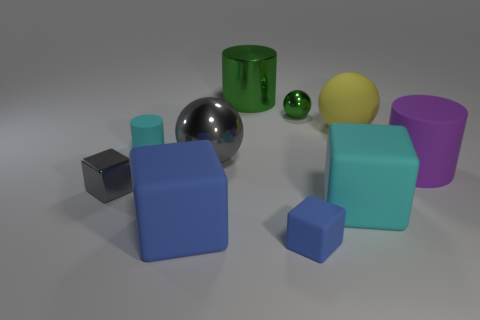Does the big object that is in front of the large cyan thing have the same color as the tiny rubber block?
Your answer should be very brief. Yes. There is a object that is both behind the large gray ball and left of the big blue matte object; what is its color?
Provide a short and direct response. Cyan. Are there any large green things made of the same material as the yellow sphere?
Offer a very short reply. No. What is the size of the gray sphere?
Ensure brevity in your answer.  Large. There is a blue cube that is left of the green thing behind the small green shiny sphere; how big is it?
Give a very brief answer. Large. What material is the other big thing that is the same shape as the big blue object?
Your answer should be very brief. Rubber. How many large cyan balls are there?
Give a very brief answer. 0. What color is the large sphere to the left of the cyan thing that is right of the green cylinder on the right side of the gray metal sphere?
Keep it short and to the point. Gray. Is the number of gray shiny cubes less than the number of small yellow matte things?
Give a very brief answer. No. There is a big shiny object that is the same shape as the small green object; what color is it?
Your response must be concise. Gray. 